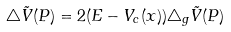<formula> <loc_0><loc_0><loc_500><loc_500>\triangle \tilde { V } ( P ) = 2 ( E - V _ { c } ( x ) ) \triangle _ { g } \tilde { V } ( P )</formula> 